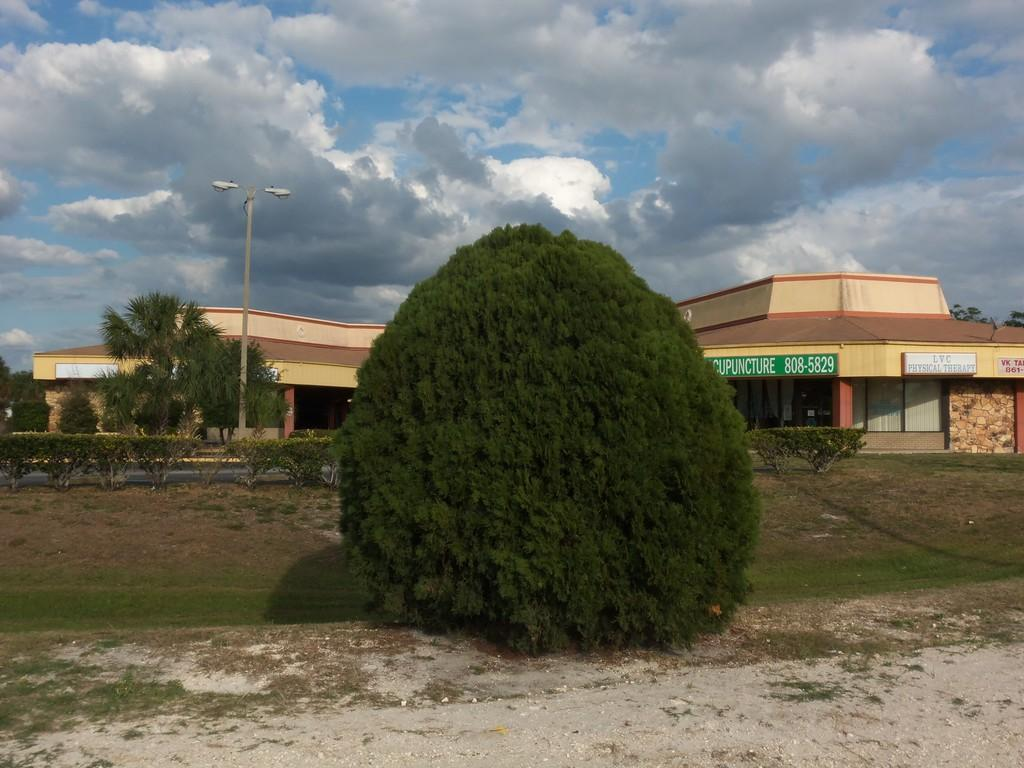What type of structure is visible in the image? There is a building in the image. What natural elements can be seen in the image? There are trees and plants in the image. What type of signage is present in the image? There are boards with text in the image. How would you describe the weather in the image? The sky is blue and cloudy in the image, suggesting a partly cloudy day. What type of lighting is present in the image? There are lights on a pole in the image. What type of air is being used to inflate the pin in the image? There is no pin present in the image, so this question cannot be answered. 